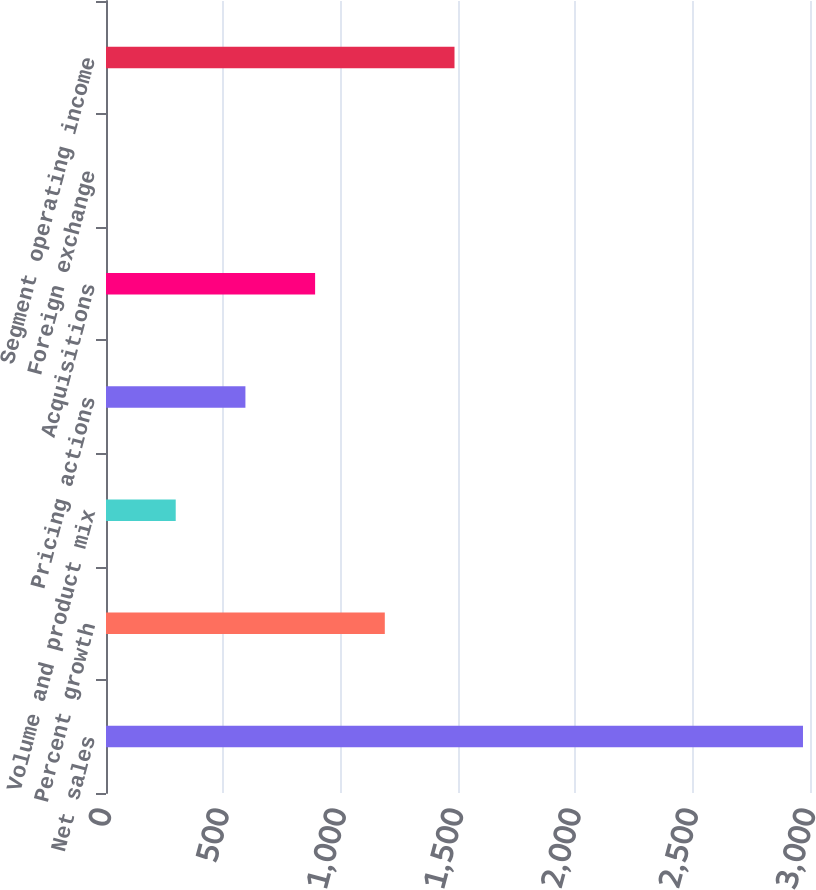Convert chart to OTSL. <chart><loc_0><loc_0><loc_500><loc_500><bar_chart><fcel>Net sales<fcel>Percent growth<fcel>Volume and product mix<fcel>Pricing actions<fcel>Acquisitions<fcel>Foreign exchange<fcel>Segment operating income<nl><fcel>2970.1<fcel>1188.1<fcel>297.1<fcel>594.1<fcel>891.1<fcel>0.1<fcel>1485.1<nl></chart> 